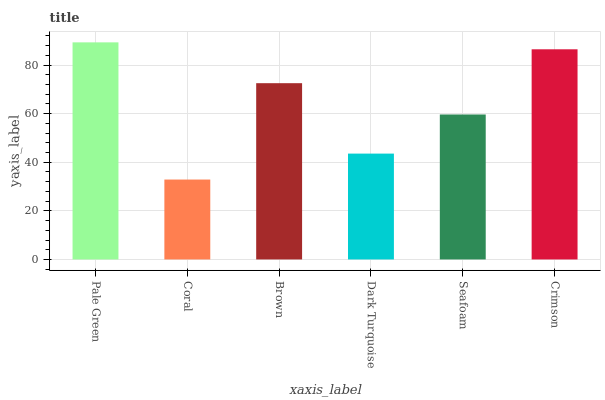Is Coral the minimum?
Answer yes or no. Yes. Is Pale Green the maximum?
Answer yes or no. Yes. Is Brown the minimum?
Answer yes or no. No. Is Brown the maximum?
Answer yes or no. No. Is Brown greater than Coral?
Answer yes or no. Yes. Is Coral less than Brown?
Answer yes or no. Yes. Is Coral greater than Brown?
Answer yes or no. No. Is Brown less than Coral?
Answer yes or no. No. Is Brown the high median?
Answer yes or no. Yes. Is Seafoam the low median?
Answer yes or no. Yes. Is Seafoam the high median?
Answer yes or no. No. Is Crimson the low median?
Answer yes or no. No. 